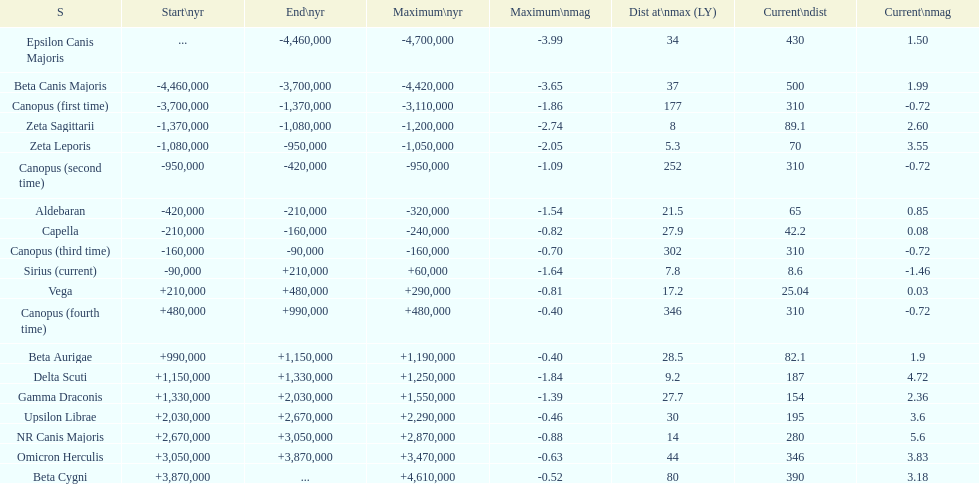How much farther (in ly) is epsilon canis majoris than zeta sagittarii? 26. 